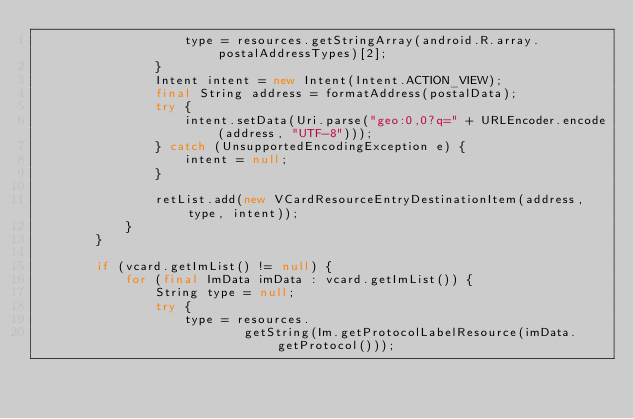Convert code to text. <code><loc_0><loc_0><loc_500><loc_500><_Java_>                    type = resources.getStringArray(android.R.array.postalAddressTypes)[2];
                }
                Intent intent = new Intent(Intent.ACTION_VIEW);
                final String address = formatAddress(postalData);
                try {
                    intent.setData(Uri.parse("geo:0,0?q=" + URLEncoder.encode(address, "UTF-8")));
                } catch (UnsupportedEncodingException e) {
                    intent = null;
                }

                retList.add(new VCardResourceEntryDestinationItem(address, type, intent));
            }
        }

        if (vcard.getImList() != null) {
            for (final ImData imData : vcard.getImList()) {
                String type = null;
                try {
                    type = resources.
                            getString(Im.getProtocolLabelResource(imData.getProtocol()));</code> 